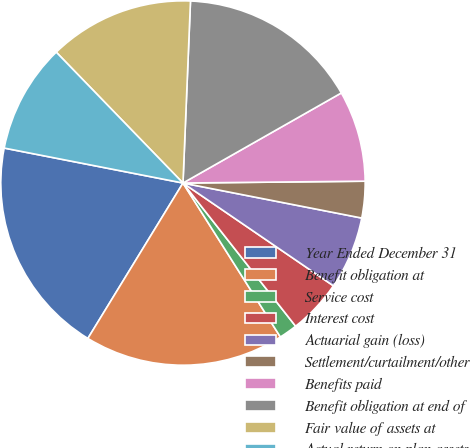<chart> <loc_0><loc_0><loc_500><loc_500><pie_chart><fcel>Year Ended December 31<fcel>Benefit obligation at<fcel>Service cost<fcel>Interest cost<fcel>Actuarial gain (loss)<fcel>Settlement/curtailment/other<fcel>Benefits paid<fcel>Benefit obligation at end of<fcel>Fair value of assets at<fcel>Actual return on plan assets<nl><fcel>19.33%<fcel>17.72%<fcel>1.63%<fcel>4.85%<fcel>6.46%<fcel>3.24%<fcel>8.07%<fcel>16.11%<fcel>12.9%<fcel>9.68%<nl></chart> 